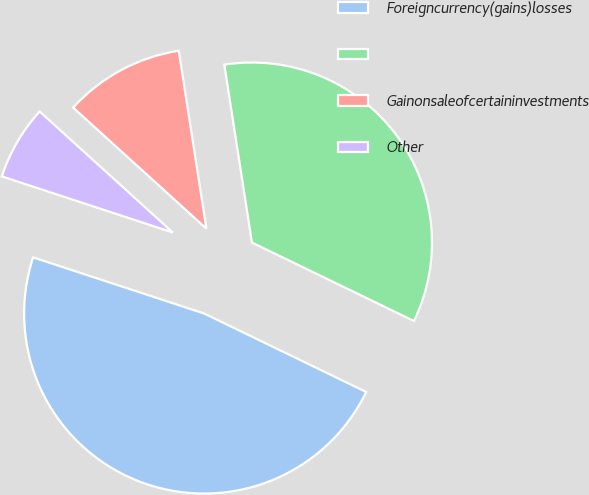Convert chart to OTSL. <chart><loc_0><loc_0><loc_500><loc_500><pie_chart><fcel>Foreigncurrency(gains)losses<fcel>Unnamed: 1<fcel>Gainonsaleofcertaininvestments<fcel>Other<nl><fcel>47.87%<fcel>34.63%<fcel>10.81%<fcel>6.69%<nl></chart> 